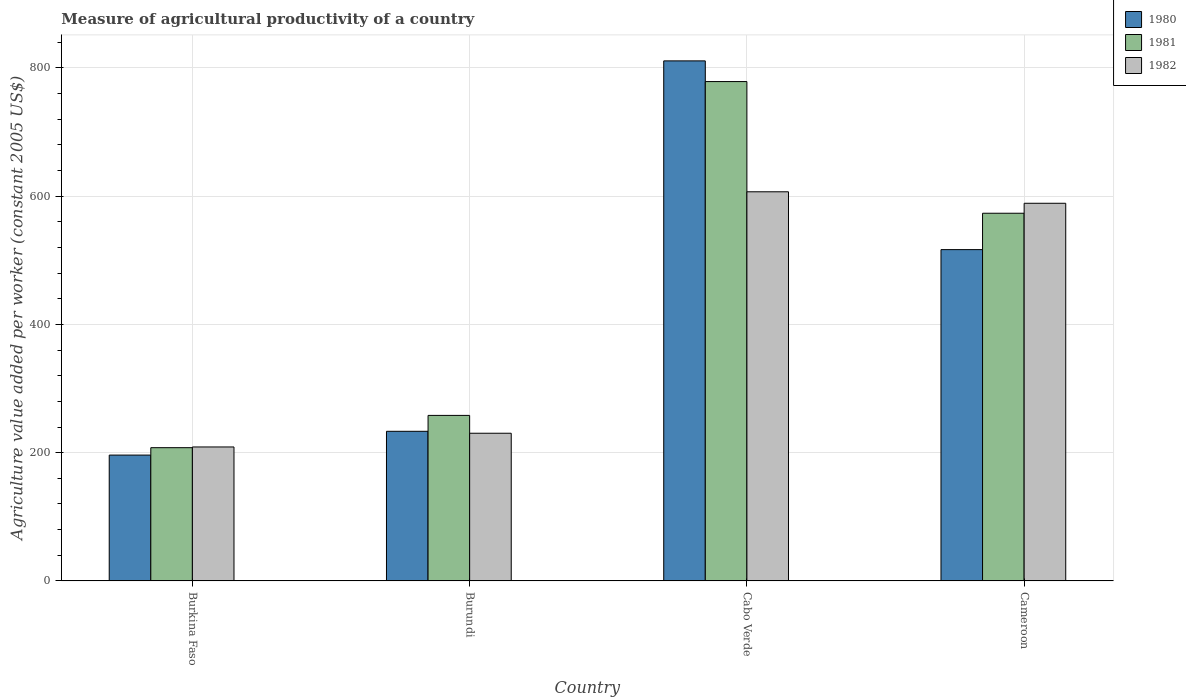Are the number of bars per tick equal to the number of legend labels?
Provide a succinct answer. Yes. How many bars are there on the 1st tick from the left?
Make the answer very short. 3. What is the label of the 4th group of bars from the left?
Your answer should be very brief. Cameroon. What is the measure of agricultural productivity in 1980 in Burundi?
Offer a terse response. 233.32. Across all countries, what is the maximum measure of agricultural productivity in 1980?
Your answer should be compact. 810.9. Across all countries, what is the minimum measure of agricultural productivity in 1980?
Offer a very short reply. 196.25. In which country was the measure of agricultural productivity in 1982 maximum?
Ensure brevity in your answer.  Cabo Verde. In which country was the measure of agricultural productivity in 1982 minimum?
Make the answer very short. Burkina Faso. What is the total measure of agricultural productivity in 1980 in the graph?
Provide a succinct answer. 1757.08. What is the difference between the measure of agricultural productivity in 1981 in Burundi and that in Cabo Verde?
Offer a terse response. -520.52. What is the difference between the measure of agricultural productivity in 1980 in Cabo Verde and the measure of agricultural productivity in 1981 in Burkina Faso?
Your response must be concise. 603.11. What is the average measure of agricultural productivity in 1981 per country?
Keep it short and to the point. 454.46. What is the difference between the measure of agricultural productivity of/in 1980 and measure of agricultural productivity of/in 1982 in Burkina Faso?
Provide a succinct answer. -12.66. In how many countries, is the measure of agricultural productivity in 1982 greater than 720 US$?
Provide a short and direct response. 0. What is the ratio of the measure of agricultural productivity in 1982 in Burkina Faso to that in Burundi?
Provide a short and direct response. 0.91. Is the measure of agricultural productivity in 1982 in Burundi less than that in Cameroon?
Offer a terse response. Yes. Is the difference between the measure of agricultural productivity in 1980 in Burkina Faso and Cameroon greater than the difference between the measure of agricultural productivity in 1982 in Burkina Faso and Cameroon?
Offer a terse response. Yes. What is the difference between the highest and the second highest measure of agricultural productivity in 1982?
Make the answer very short. -17.9. What is the difference between the highest and the lowest measure of agricultural productivity in 1980?
Offer a very short reply. 614.65. Is the sum of the measure of agricultural productivity in 1982 in Burkina Faso and Burundi greater than the maximum measure of agricultural productivity in 1981 across all countries?
Provide a short and direct response. No. What does the 3rd bar from the right in Cabo Verde represents?
Your answer should be compact. 1980. How many countries are there in the graph?
Keep it short and to the point. 4. Does the graph contain grids?
Offer a very short reply. Yes. Where does the legend appear in the graph?
Your response must be concise. Top right. How many legend labels are there?
Keep it short and to the point. 3. How are the legend labels stacked?
Your answer should be very brief. Vertical. What is the title of the graph?
Your answer should be very brief. Measure of agricultural productivity of a country. Does "1988" appear as one of the legend labels in the graph?
Ensure brevity in your answer.  No. What is the label or title of the Y-axis?
Offer a terse response. Agriculture value added per worker (constant 2005 US$). What is the Agriculture value added per worker (constant 2005 US$) in 1980 in Burkina Faso?
Offer a very short reply. 196.25. What is the Agriculture value added per worker (constant 2005 US$) of 1981 in Burkina Faso?
Your answer should be very brief. 207.78. What is the Agriculture value added per worker (constant 2005 US$) in 1982 in Burkina Faso?
Ensure brevity in your answer.  208.91. What is the Agriculture value added per worker (constant 2005 US$) of 1980 in Burundi?
Offer a terse response. 233.32. What is the Agriculture value added per worker (constant 2005 US$) in 1981 in Burundi?
Provide a short and direct response. 258.11. What is the Agriculture value added per worker (constant 2005 US$) in 1982 in Burundi?
Keep it short and to the point. 230.29. What is the Agriculture value added per worker (constant 2005 US$) in 1980 in Cabo Verde?
Your response must be concise. 810.9. What is the Agriculture value added per worker (constant 2005 US$) of 1981 in Cabo Verde?
Give a very brief answer. 778.63. What is the Agriculture value added per worker (constant 2005 US$) of 1982 in Cabo Verde?
Your answer should be very brief. 606.77. What is the Agriculture value added per worker (constant 2005 US$) in 1980 in Cameroon?
Provide a succinct answer. 516.62. What is the Agriculture value added per worker (constant 2005 US$) in 1981 in Cameroon?
Provide a succinct answer. 573.32. What is the Agriculture value added per worker (constant 2005 US$) in 1982 in Cameroon?
Offer a terse response. 588.87. Across all countries, what is the maximum Agriculture value added per worker (constant 2005 US$) in 1980?
Your answer should be very brief. 810.9. Across all countries, what is the maximum Agriculture value added per worker (constant 2005 US$) of 1981?
Your answer should be very brief. 778.63. Across all countries, what is the maximum Agriculture value added per worker (constant 2005 US$) of 1982?
Provide a succinct answer. 606.77. Across all countries, what is the minimum Agriculture value added per worker (constant 2005 US$) of 1980?
Your answer should be very brief. 196.25. Across all countries, what is the minimum Agriculture value added per worker (constant 2005 US$) in 1981?
Provide a short and direct response. 207.78. Across all countries, what is the minimum Agriculture value added per worker (constant 2005 US$) of 1982?
Offer a very short reply. 208.91. What is the total Agriculture value added per worker (constant 2005 US$) in 1980 in the graph?
Offer a very short reply. 1757.08. What is the total Agriculture value added per worker (constant 2005 US$) in 1981 in the graph?
Provide a succinct answer. 1817.84. What is the total Agriculture value added per worker (constant 2005 US$) of 1982 in the graph?
Keep it short and to the point. 1634.84. What is the difference between the Agriculture value added per worker (constant 2005 US$) of 1980 in Burkina Faso and that in Burundi?
Your answer should be compact. -37.08. What is the difference between the Agriculture value added per worker (constant 2005 US$) of 1981 in Burkina Faso and that in Burundi?
Offer a very short reply. -50.33. What is the difference between the Agriculture value added per worker (constant 2005 US$) of 1982 in Burkina Faso and that in Burundi?
Your answer should be very brief. -21.37. What is the difference between the Agriculture value added per worker (constant 2005 US$) of 1980 in Burkina Faso and that in Cabo Verde?
Keep it short and to the point. -614.65. What is the difference between the Agriculture value added per worker (constant 2005 US$) of 1981 in Burkina Faso and that in Cabo Verde?
Your response must be concise. -570.85. What is the difference between the Agriculture value added per worker (constant 2005 US$) in 1982 in Burkina Faso and that in Cabo Verde?
Keep it short and to the point. -397.86. What is the difference between the Agriculture value added per worker (constant 2005 US$) of 1980 in Burkina Faso and that in Cameroon?
Provide a succinct answer. -320.37. What is the difference between the Agriculture value added per worker (constant 2005 US$) of 1981 in Burkina Faso and that in Cameroon?
Make the answer very short. -365.54. What is the difference between the Agriculture value added per worker (constant 2005 US$) of 1982 in Burkina Faso and that in Cameroon?
Give a very brief answer. -379.96. What is the difference between the Agriculture value added per worker (constant 2005 US$) in 1980 in Burundi and that in Cabo Verde?
Offer a very short reply. -577.57. What is the difference between the Agriculture value added per worker (constant 2005 US$) in 1981 in Burundi and that in Cabo Verde?
Offer a very short reply. -520.52. What is the difference between the Agriculture value added per worker (constant 2005 US$) of 1982 in Burundi and that in Cabo Verde?
Your response must be concise. -376.49. What is the difference between the Agriculture value added per worker (constant 2005 US$) in 1980 in Burundi and that in Cameroon?
Offer a terse response. -283.29. What is the difference between the Agriculture value added per worker (constant 2005 US$) of 1981 in Burundi and that in Cameroon?
Offer a very short reply. -315.21. What is the difference between the Agriculture value added per worker (constant 2005 US$) of 1982 in Burundi and that in Cameroon?
Provide a succinct answer. -358.59. What is the difference between the Agriculture value added per worker (constant 2005 US$) in 1980 in Cabo Verde and that in Cameroon?
Provide a short and direct response. 294.28. What is the difference between the Agriculture value added per worker (constant 2005 US$) in 1981 in Cabo Verde and that in Cameroon?
Provide a short and direct response. 205.31. What is the difference between the Agriculture value added per worker (constant 2005 US$) in 1982 in Cabo Verde and that in Cameroon?
Make the answer very short. 17.9. What is the difference between the Agriculture value added per worker (constant 2005 US$) in 1980 in Burkina Faso and the Agriculture value added per worker (constant 2005 US$) in 1981 in Burundi?
Provide a short and direct response. -61.86. What is the difference between the Agriculture value added per worker (constant 2005 US$) of 1980 in Burkina Faso and the Agriculture value added per worker (constant 2005 US$) of 1982 in Burundi?
Your response must be concise. -34.04. What is the difference between the Agriculture value added per worker (constant 2005 US$) of 1981 in Burkina Faso and the Agriculture value added per worker (constant 2005 US$) of 1982 in Burundi?
Keep it short and to the point. -22.5. What is the difference between the Agriculture value added per worker (constant 2005 US$) in 1980 in Burkina Faso and the Agriculture value added per worker (constant 2005 US$) in 1981 in Cabo Verde?
Ensure brevity in your answer.  -582.38. What is the difference between the Agriculture value added per worker (constant 2005 US$) in 1980 in Burkina Faso and the Agriculture value added per worker (constant 2005 US$) in 1982 in Cabo Verde?
Provide a succinct answer. -410.52. What is the difference between the Agriculture value added per worker (constant 2005 US$) of 1981 in Burkina Faso and the Agriculture value added per worker (constant 2005 US$) of 1982 in Cabo Verde?
Provide a succinct answer. -398.99. What is the difference between the Agriculture value added per worker (constant 2005 US$) of 1980 in Burkina Faso and the Agriculture value added per worker (constant 2005 US$) of 1981 in Cameroon?
Offer a very short reply. -377.07. What is the difference between the Agriculture value added per worker (constant 2005 US$) of 1980 in Burkina Faso and the Agriculture value added per worker (constant 2005 US$) of 1982 in Cameroon?
Make the answer very short. -392.63. What is the difference between the Agriculture value added per worker (constant 2005 US$) in 1981 in Burkina Faso and the Agriculture value added per worker (constant 2005 US$) in 1982 in Cameroon?
Offer a terse response. -381.09. What is the difference between the Agriculture value added per worker (constant 2005 US$) of 1980 in Burundi and the Agriculture value added per worker (constant 2005 US$) of 1981 in Cabo Verde?
Your response must be concise. -545.31. What is the difference between the Agriculture value added per worker (constant 2005 US$) of 1980 in Burundi and the Agriculture value added per worker (constant 2005 US$) of 1982 in Cabo Verde?
Give a very brief answer. -373.45. What is the difference between the Agriculture value added per worker (constant 2005 US$) in 1981 in Burundi and the Agriculture value added per worker (constant 2005 US$) in 1982 in Cabo Verde?
Offer a terse response. -348.66. What is the difference between the Agriculture value added per worker (constant 2005 US$) in 1980 in Burundi and the Agriculture value added per worker (constant 2005 US$) in 1981 in Cameroon?
Your response must be concise. -340. What is the difference between the Agriculture value added per worker (constant 2005 US$) in 1980 in Burundi and the Agriculture value added per worker (constant 2005 US$) in 1982 in Cameroon?
Offer a terse response. -355.55. What is the difference between the Agriculture value added per worker (constant 2005 US$) in 1981 in Burundi and the Agriculture value added per worker (constant 2005 US$) in 1982 in Cameroon?
Give a very brief answer. -330.76. What is the difference between the Agriculture value added per worker (constant 2005 US$) of 1980 in Cabo Verde and the Agriculture value added per worker (constant 2005 US$) of 1981 in Cameroon?
Make the answer very short. 237.58. What is the difference between the Agriculture value added per worker (constant 2005 US$) of 1980 in Cabo Verde and the Agriculture value added per worker (constant 2005 US$) of 1982 in Cameroon?
Keep it short and to the point. 222.02. What is the difference between the Agriculture value added per worker (constant 2005 US$) in 1981 in Cabo Verde and the Agriculture value added per worker (constant 2005 US$) in 1982 in Cameroon?
Offer a terse response. 189.76. What is the average Agriculture value added per worker (constant 2005 US$) of 1980 per country?
Offer a very short reply. 439.27. What is the average Agriculture value added per worker (constant 2005 US$) in 1981 per country?
Offer a terse response. 454.46. What is the average Agriculture value added per worker (constant 2005 US$) in 1982 per country?
Provide a short and direct response. 408.71. What is the difference between the Agriculture value added per worker (constant 2005 US$) of 1980 and Agriculture value added per worker (constant 2005 US$) of 1981 in Burkina Faso?
Offer a very short reply. -11.54. What is the difference between the Agriculture value added per worker (constant 2005 US$) of 1980 and Agriculture value added per worker (constant 2005 US$) of 1982 in Burkina Faso?
Make the answer very short. -12.66. What is the difference between the Agriculture value added per worker (constant 2005 US$) of 1981 and Agriculture value added per worker (constant 2005 US$) of 1982 in Burkina Faso?
Provide a succinct answer. -1.13. What is the difference between the Agriculture value added per worker (constant 2005 US$) in 1980 and Agriculture value added per worker (constant 2005 US$) in 1981 in Burundi?
Give a very brief answer. -24.79. What is the difference between the Agriculture value added per worker (constant 2005 US$) in 1980 and Agriculture value added per worker (constant 2005 US$) in 1982 in Burundi?
Keep it short and to the point. 3.04. What is the difference between the Agriculture value added per worker (constant 2005 US$) of 1981 and Agriculture value added per worker (constant 2005 US$) of 1982 in Burundi?
Your answer should be compact. 27.82. What is the difference between the Agriculture value added per worker (constant 2005 US$) in 1980 and Agriculture value added per worker (constant 2005 US$) in 1981 in Cabo Verde?
Keep it short and to the point. 32.27. What is the difference between the Agriculture value added per worker (constant 2005 US$) of 1980 and Agriculture value added per worker (constant 2005 US$) of 1982 in Cabo Verde?
Provide a short and direct response. 204.13. What is the difference between the Agriculture value added per worker (constant 2005 US$) in 1981 and Agriculture value added per worker (constant 2005 US$) in 1982 in Cabo Verde?
Your answer should be compact. 171.86. What is the difference between the Agriculture value added per worker (constant 2005 US$) in 1980 and Agriculture value added per worker (constant 2005 US$) in 1981 in Cameroon?
Your answer should be very brief. -56.7. What is the difference between the Agriculture value added per worker (constant 2005 US$) of 1980 and Agriculture value added per worker (constant 2005 US$) of 1982 in Cameroon?
Ensure brevity in your answer.  -72.26. What is the difference between the Agriculture value added per worker (constant 2005 US$) of 1981 and Agriculture value added per worker (constant 2005 US$) of 1982 in Cameroon?
Offer a very short reply. -15.55. What is the ratio of the Agriculture value added per worker (constant 2005 US$) of 1980 in Burkina Faso to that in Burundi?
Give a very brief answer. 0.84. What is the ratio of the Agriculture value added per worker (constant 2005 US$) in 1981 in Burkina Faso to that in Burundi?
Make the answer very short. 0.81. What is the ratio of the Agriculture value added per worker (constant 2005 US$) in 1982 in Burkina Faso to that in Burundi?
Your answer should be very brief. 0.91. What is the ratio of the Agriculture value added per worker (constant 2005 US$) in 1980 in Burkina Faso to that in Cabo Verde?
Your answer should be compact. 0.24. What is the ratio of the Agriculture value added per worker (constant 2005 US$) in 1981 in Burkina Faso to that in Cabo Verde?
Offer a very short reply. 0.27. What is the ratio of the Agriculture value added per worker (constant 2005 US$) of 1982 in Burkina Faso to that in Cabo Verde?
Offer a terse response. 0.34. What is the ratio of the Agriculture value added per worker (constant 2005 US$) of 1980 in Burkina Faso to that in Cameroon?
Provide a succinct answer. 0.38. What is the ratio of the Agriculture value added per worker (constant 2005 US$) in 1981 in Burkina Faso to that in Cameroon?
Make the answer very short. 0.36. What is the ratio of the Agriculture value added per worker (constant 2005 US$) of 1982 in Burkina Faso to that in Cameroon?
Your answer should be very brief. 0.35. What is the ratio of the Agriculture value added per worker (constant 2005 US$) in 1980 in Burundi to that in Cabo Verde?
Your response must be concise. 0.29. What is the ratio of the Agriculture value added per worker (constant 2005 US$) of 1981 in Burundi to that in Cabo Verde?
Your answer should be compact. 0.33. What is the ratio of the Agriculture value added per worker (constant 2005 US$) in 1982 in Burundi to that in Cabo Verde?
Give a very brief answer. 0.38. What is the ratio of the Agriculture value added per worker (constant 2005 US$) of 1980 in Burundi to that in Cameroon?
Ensure brevity in your answer.  0.45. What is the ratio of the Agriculture value added per worker (constant 2005 US$) in 1981 in Burundi to that in Cameroon?
Ensure brevity in your answer.  0.45. What is the ratio of the Agriculture value added per worker (constant 2005 US$) of 1982 in Burundi to that in Cameroon?
Your answer should be very brief. 0.39. What is the ratio of the Agriculture value added per worker (constant 2005 US$) in 1980 in Cabo Verde to that in Cameroon?
Your response must be concise. 1.57. What is the ratio of the Agriculture value added per worker (constant 2005 US$) of 1981 in Cabo Verde to that in Cameroon?
Offer a very short reply. 1.36. What is the ratio of the Agriculture value added per worker (constant 2005 US$) in 1982 in Cabo Verde to that in Cameroon?
Offer a very short reply. 1.03. What is the difference between the highest and the second highest Agriculture value added per worker (constant 2005 US$) in 1980?
Offer a terse response. 294.28. What is the difference between the highest and the second highest Agriculture value added per worker (constant 2005 US$) of 1981?
Your answer should be very brief. 205.31. What is the difference between the highest and the second highest Agriculture value added per worker (constant 2005 US$) of 1982?
Offer a very short reply. 17.9. What is the difference between the highest and the lowest Agriculture value added per worker (constant 2005 US$) in 1980?
Give a very brief answer. 614.65. What is the difference between the highest and the lowest Agriculture value added per worker (constant 2005 US$) in 1981?
Keep it short and to the point. 570.85. What is the difference between the highest and the lowest Agriculture value added per worker (constant 2005 US$) of 1982?
Provide a succinct answer. 397.86. 